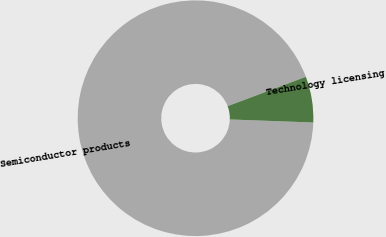<chart> <loc_0><loc_0><loc_500><loc_500><pie_chart><fcel>Semiconductor products<fcel>Technology licensing<nl><fcel>93.71%<fcel>6.29%<nl></chart> 